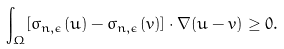Convert formula to latex. <formula><loc_0><loc_0><loc_500><loc_500>\int _ { \Omega } [ \sigma _ { n , \epsilon } ( u ) - \sigma _ { n , \epsilon } ( v ) ] \cdot \nabla ( u - v ) \geq 0 .</formula> 